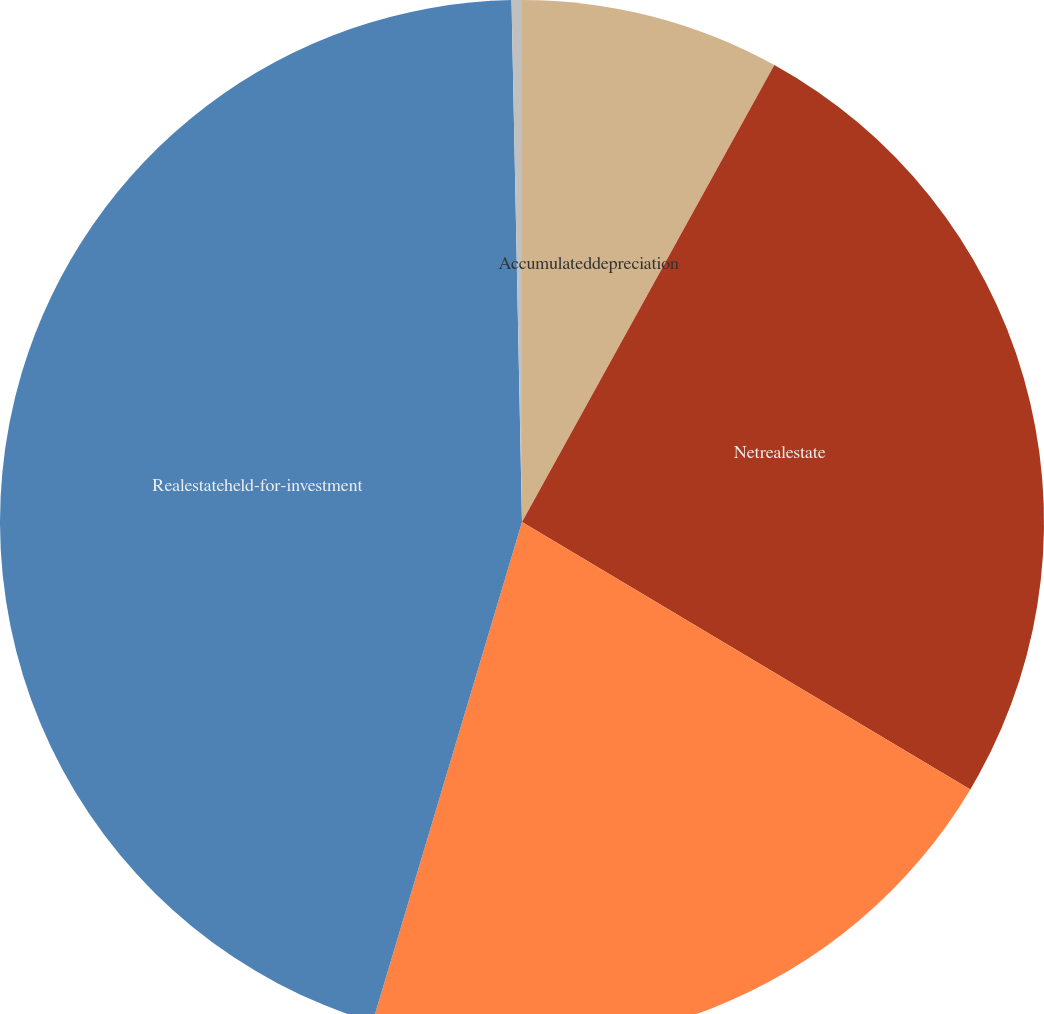<chart> <loc_0><loc_0><loc_500><loc_500><pie_chart><fcel>Accumulateddepreciation<fcel>Netrealestate<fcel>Unnamed: 2<fcel>Realestateheld-for-investment<fcel>Realestateheld-for-sale<nl><fcel>8.03%<fcel>25.53%<fcel>21.06%<fcel>45.06%<fcel>0.32%<nl></chart> 